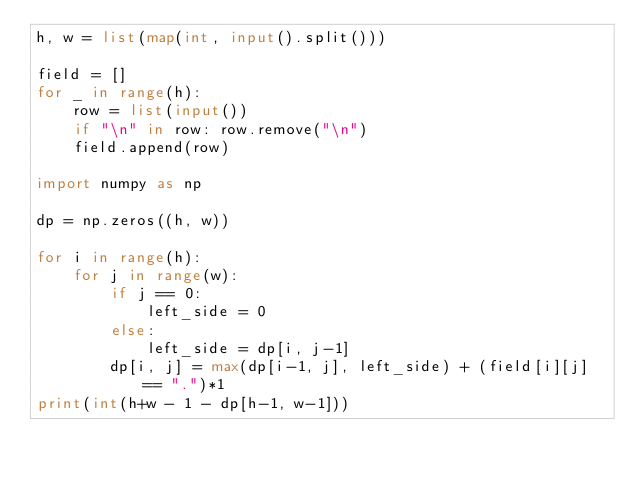<code> <loc_0><loc_0><loc_500><loc_500><_Python_>h, w = list(map(int, input().split()))

field = []
for _ in range(h):
    row = list(input())
    if "\n" in row: row.remove("\n")
    field.append(row)

import numpy as np

dp = np.zeros((h, w))

for i in range(h):
    for j in range(w):
        if j == 0:
            left_side = 0
        else:
            left_side = dp[i, j-1]
        dp[i, j] = max(dp[i-1, j], left_side) + (field[i][j] == ".")*1
print(int(h+w - 1 - dp[h-1, w-1]))</code> 